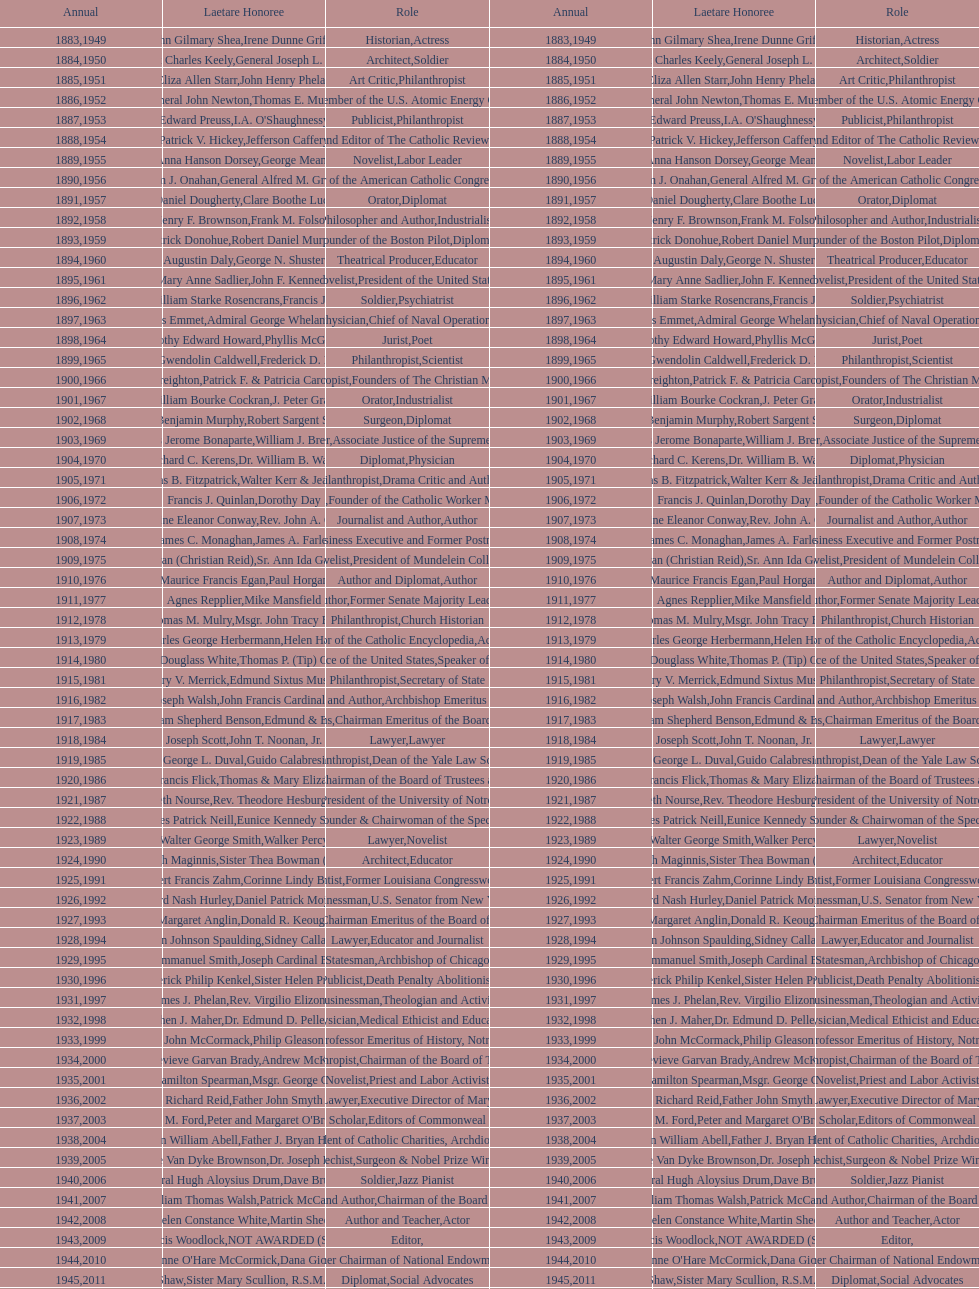What are the number of laetare medalist that held a diplomat position? 8. 